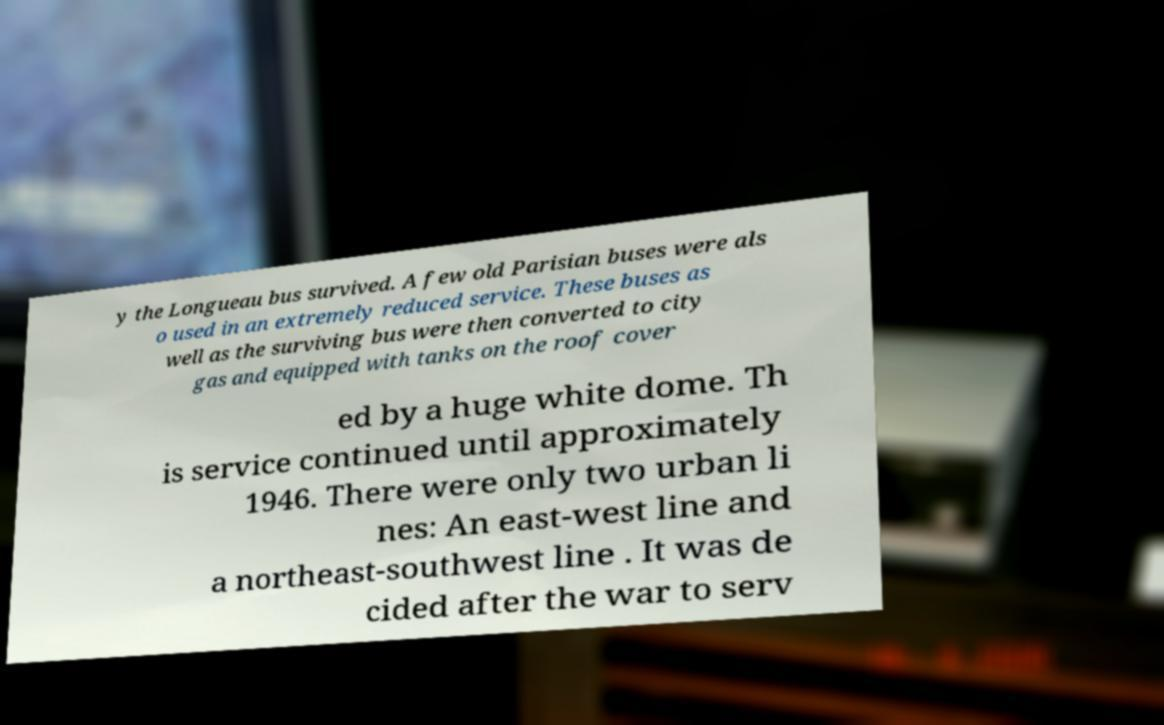Please read and relay the text visible in this image. What does it say? y the Longueau bus survived. A few old Parisian buses were als o used in an extremely reduced service. These buses as well as the surviving bus were then converted to city gas and equipped with tanks on the roof cover ed by a huge white dome. Th is service continued until approximately 1946. There were only two urban li nes: An east-west line and a northeast-southwest line . It was de cided after the war to serv 